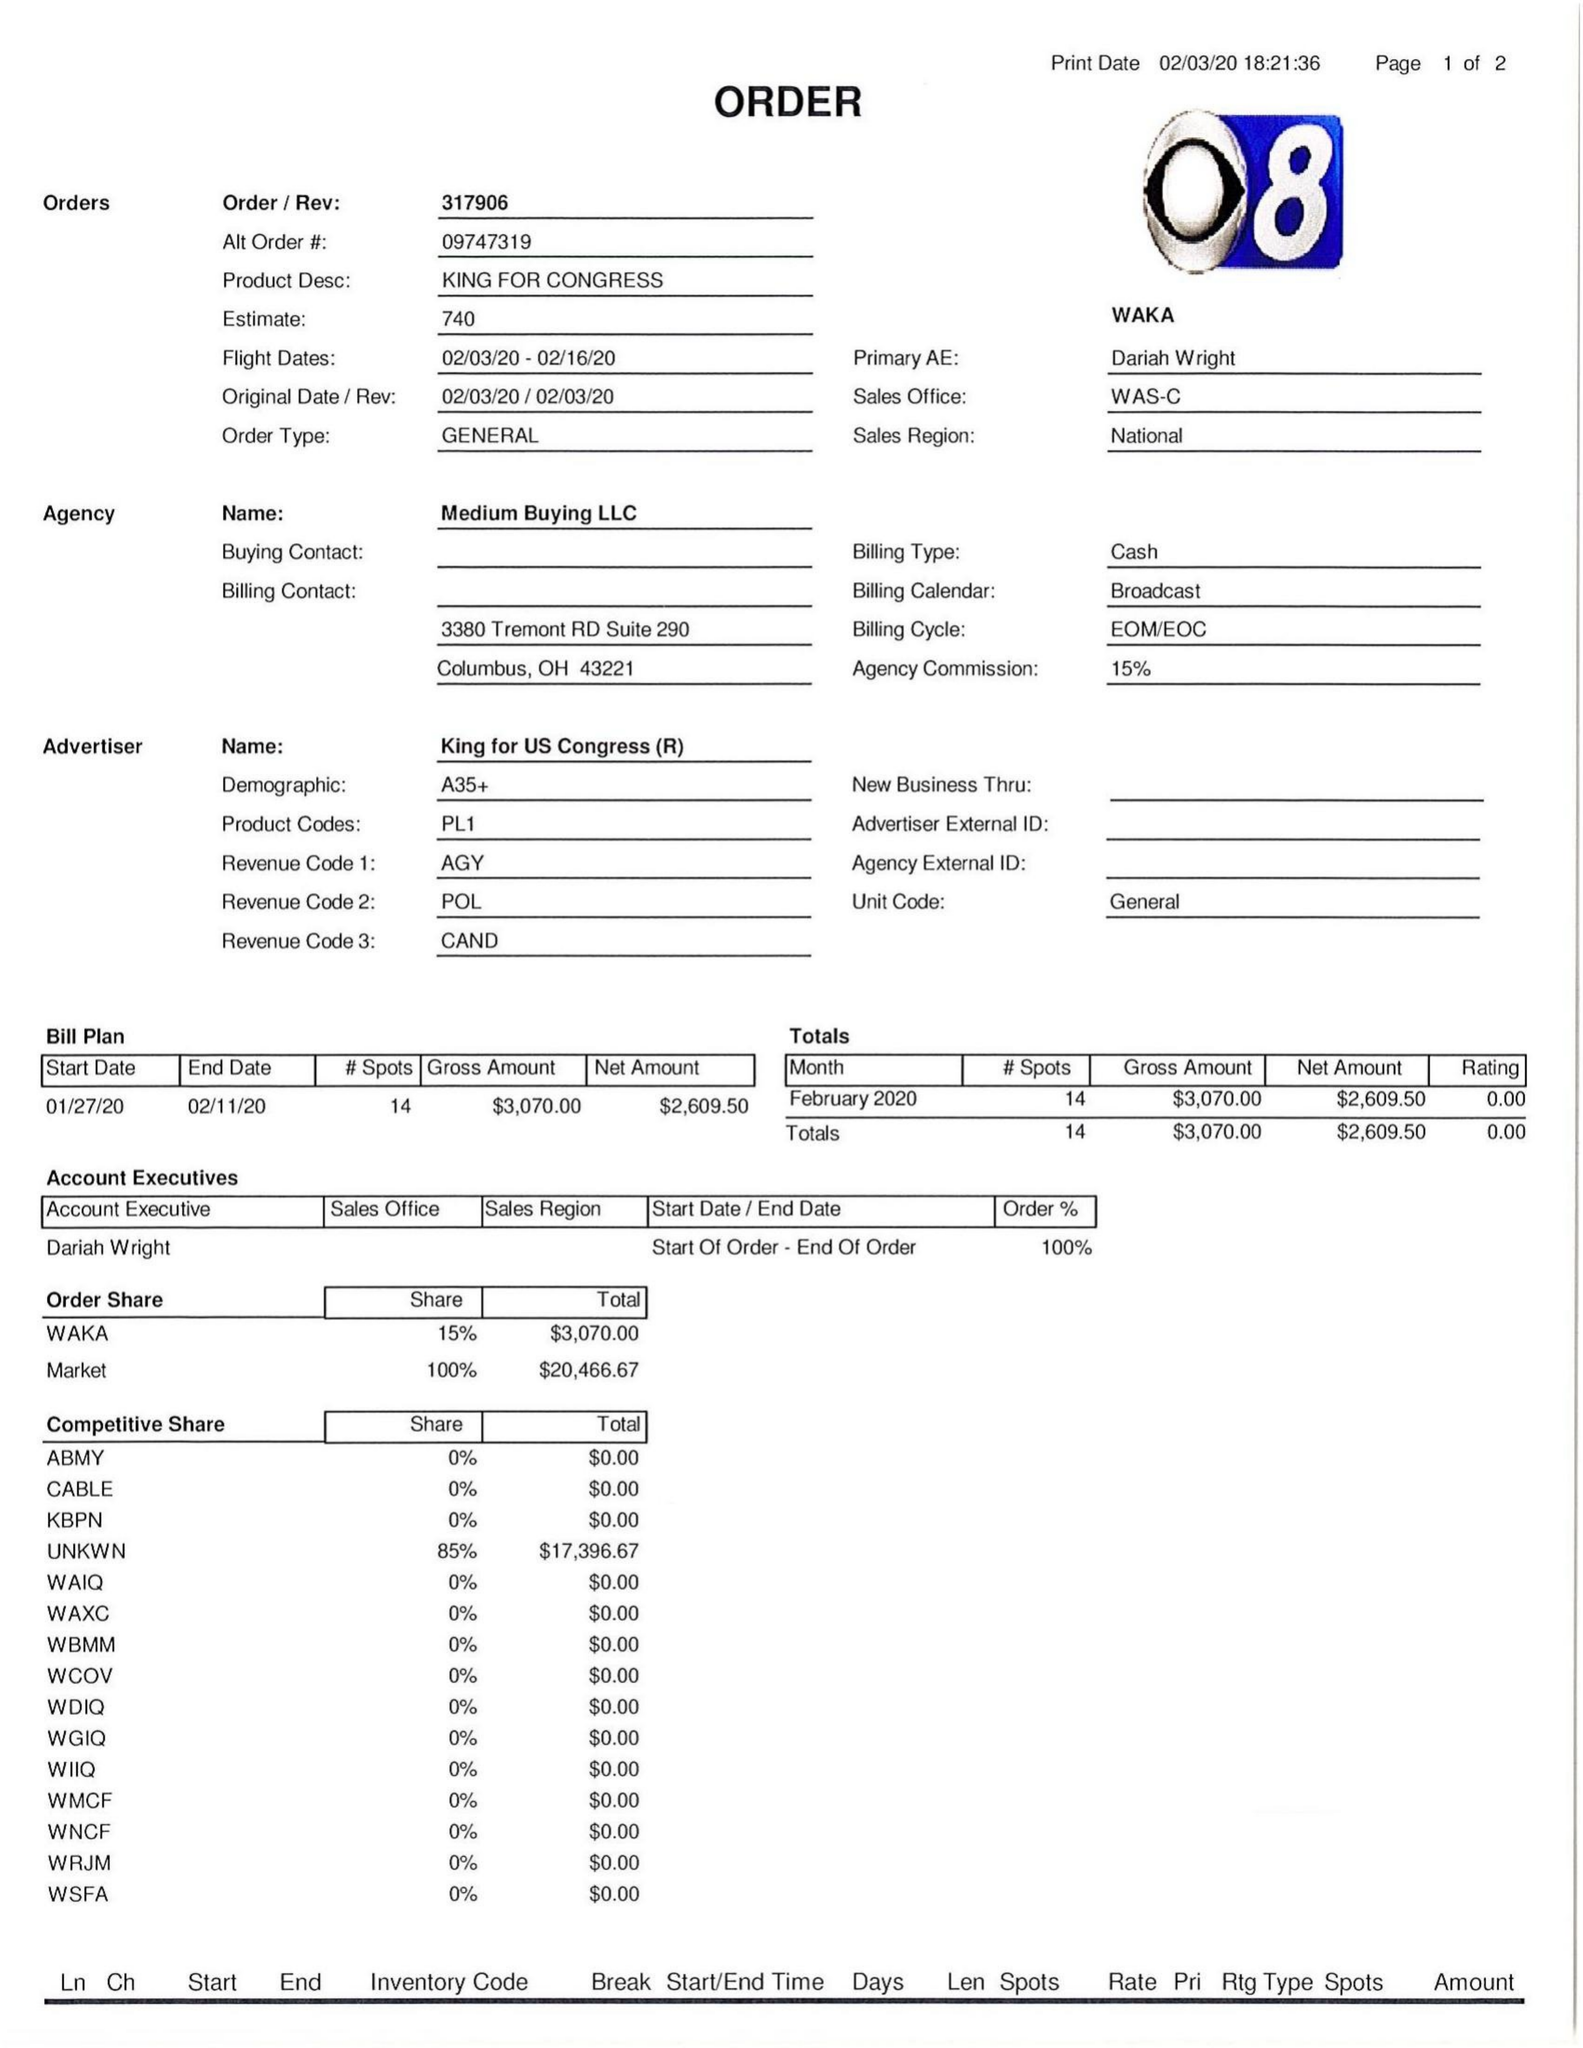What is the value for the flight_to?
Answer the question using a single word or phrase. 02/16/20 